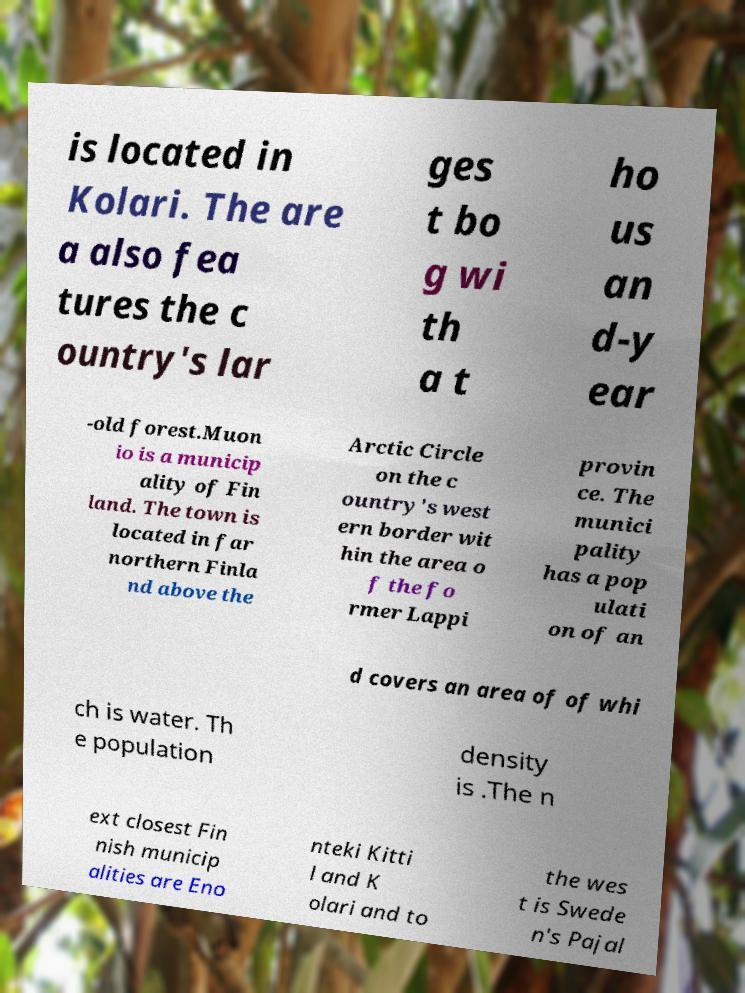I need the written content from this picture converted into text. Can you do that? is located in Kolari. The are a also fea tures the c ountry's lar ges t bo g wi th a t ho us an d-y ear -old forest.Muon io is a municip ality of Fin land. The town is located in far northern Finla nd above the Arctic Circle on the c ountry's west ern border wit hin the area o f the fo rmer Lappi provin ce. The munici pality has a pop ulati on of an d covers an area of of whi ch is water. Th e population density is .The n ext closest Fin nish municip alities are Eno nteki Kitti l and K olari and to the wes t is Swede n's Pajal 